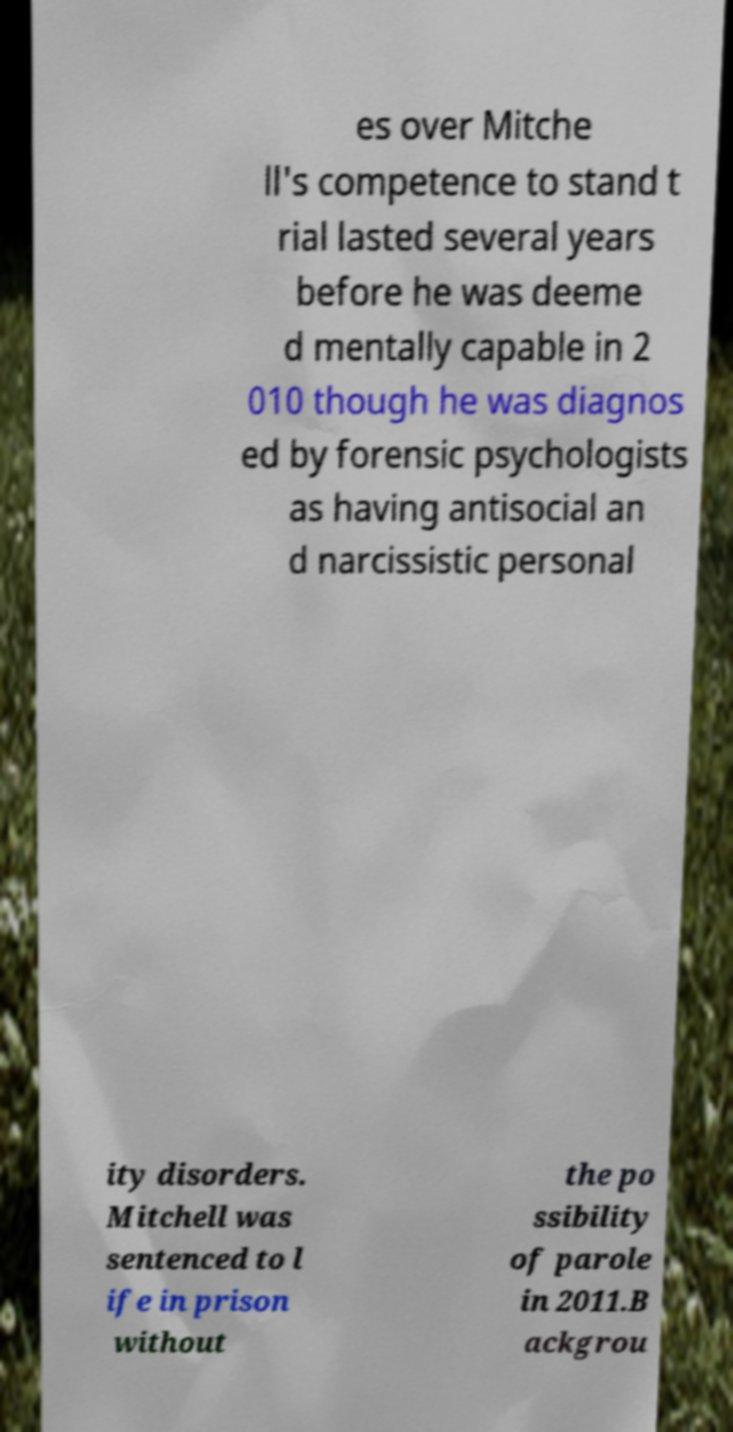Please identify and transcribe the text found in this image. es over Mitche ll's competence to stand t rial lasted several years before he was deeme d mentally capable in 2 010 though he was diagnos ed by forensic psychologists as having antisocial an d narcissistic personal ity disorders. Mitchell was sentenced to l ife in prison without the po ssibility of parole in 2011.B ackgrou 